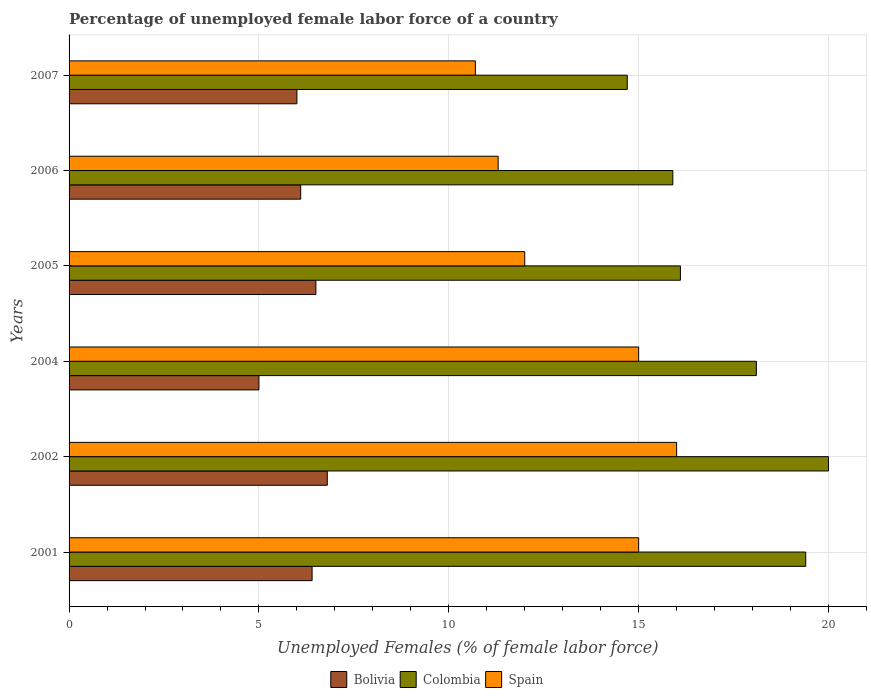How many groups of bars are there?
Provide a short and direct response. 6. Are the number of bars on each tick of the Y-axis equal?
Your answer should be very brief. Yes. How many bars are there on the 6th tick from the top?
Ensure brevity in your answer.  3. How many bars are there on the 2nd tick from the bottom?
Your response must be concise. 3. What is the label of the 4th group of bars from the top?
Ensure brevity in your answer.  2004. What is the percentage of unemployed female labor force in Colombia in 2004?
Your answer should be very brief. 18.1. Across all years, what is the maximum percentage of unemployed female labor force in Colombia?
Provide a succinct answer. 20. What is the total percentage of unemployed female labor force in Spain in the graph?
Provide a short and direct response. 80. What is the difference between the percentage of unemployed female labor force in Spain in 2004 and that in 2005?
Your response must be concise. 3. What is the average percentage of unemployed female labor force in Colombia per year?
Provide a succinct answer. 17.37. In the year 2007, what is the difference between the percentage of unemployed female labor force in Bolivia and percentage of unemployed female labor force in Colombia?
Provide a succinct answer. -8.7. What is the ratio of the percentage of unemployed female labor force in Spain in 2002 to that in 2007?
Provide a short and direct response. 1.5. What is the difference between the highest and the second highest percentage of unemployed female labor force in Colombia?
Offer a terse response. 0.6. What is the difference between the highest and the lowest percentage of unemployed female labor force in Bolivia?
Provide a succinct answer. 1.8. How many bars are there?
Your response must be concise. 18. How many years are there in the graph?
Give a very brief answer. 6. What is the difference between two consecutive major ticks on the X-axis?
Keep it short and to the point. 5. Are the values on the major ticks of X-axis written in scientific E-notation?
Offer a terse response. No. Does the graph contain grids?
Your answer should be very brief. Yes. Where does the legend appear in the graph?
Give a very brief answer. Bottom center. How many legend labels are there?
Offer a terse response. 3. What is the title of the graph?
Your answer should be compact. Percentage of unemployed female labor force of a country. What is the label or title of the X-axis?
Ensure brevity in your answer.  Unemployed Females (% of female labor force). What is the label or title of the Y-axis?
Provide a short and direct response. Years. What is the Unemployed Females (% of female labor force) of Bolivia in 2001?
Ensure brevity in your answer.  6.4. What is the Unemployed Females (% of female labor force) of Colombia in 2001?
Your response must be concise. 19.4. What is the Unemployed Females (% of female labor force) in Spain in 2001?
Provide a short and direct response. 15. What is the Unemployed Females (% of female labor force) in Bolivia in 2002?
Your response must be concise. 6.8. What is the Unemployed Females (% of female labor force) of Colombia in 2002?
Your response must be concise. 20. What is the Unemployed Females (% of female labor force) in Colombia in 2004?
Your response must be concise. 18.1. What is the Unemployed Females (% of female labor force) in Spain in 2004?
Provide a succinct answer. 15. What is the Unemployed Females (% of female labor force) of Colombia in 2005?
Provide a short and direct response. 16.1. What is the Unemployed Females (% of female labor force) of Spain in 2005?
Ensure brevity in your answer.  12. What is the Unemployed Females (% of female labor force) of Bolivia in 2006?
Provide a succinct answer. 6.1. What is the Unemployed Females (% of female labor force) in Colombia in 2006?
Your answer should be very brief. 15.9. What is the Unemployed Females (% of female labor force) in Spain in 2006?
Your answer should be compact. 11.3. What is the Unemployed Females (% of female labor force) of Bolivia in 2007?
Your answer should be very brief. 6. What is the Unemployed Females (% of female labor force) in Colombia in 2007?
Your answer should be very brief. 14.7. What is the Unemployed Females (% of female labor force) in Spain in 2007?
Provide a short and direct response. 10.7. Across all years, what is the maximum Unemployed Females (% of female labor force) in Bolivia?
Give a very brief answer. 6.8. Across all years, what is the minimum Unemployed Females (% of female labor force) of Bolivia?
Offer a terse response. 5. Across all years, what is the minimum Unemployed Females (% of female labor force) of Colombia?
Provide a short and direct response. 14.7. Across all years, what is the minimum Unemployed Females (% of female labor force) of Spain?
Your answer should be very brief. 10.7. What is the total Unemployed Females (% of female labor force) in Bolivia in the graph?
Keep it short and to the point. 36.8. What is the total Unemployed Females (% of female labor force) in Colombia in the graph?
Your answer should be compact. 104.2. What is the total Unemployed Females (% of female labor force) of Spain in the graph?
Ensure brevity in your answer.  80. What is the difference between the Unemployed Females (% of female labor force) in Spain in 2001 and that in 2002?
Keep it short and to the point. -1. What is the difference between the Unemployed Females (% of female labor force) of Bolivia in 2001 and that in 2004?
Your answer should be compact. 1.4. What is the difference between the Unemployed Females (% of female labor force) of Spain in 2001 and that in 2004?
Ensure brevity in your answer.  0. What is the difference between the Unemployed Females (% of female labor force) in Bolivia in 2001 and that in 2005?
Offer a terse response. -0.1. What is the difference between the Unemployed Females (% of female labor force) in Colombia in 2001 and that in 2005?
Make the answer very short. 3.3. What is the difference between the Unemployed Females (% of female labor force) of Spain in 2001 and that in 2006?
Ensure brevity in your answer.  3.7. What is the difference between the Unemployed Females (% of female labor force) of Spain in 2001 and that in 2007?
Offer a very short reply. 4.3. What is the difference between the Unemployed Females (% of female labor force) of Bolivia in 2002 and that in 2005?
Ensure brevity in your answer.  0.3. What is the difference between the Unemployed Females (% of female labor force) of Colombia in 2002 and that in 2005?
Make the answer very short. 3.9. What is the difference between the Unemployed Females (% of female labor force) in Spain in 2002 and that in 2005?
Provide a succinct answer. 4. What is the difference between the Unemployed Females (% of female labor force) in Spain in 2002 and that in 2006?
Offer a terse response. 4.7. What is the difference between the Unemployed Females (% of female labor force) of Colombia in 2002 and that in 2007?
Keep it short and to the point. 5.3. What is the difference between the Unemployed Females (% of female labor force) in Bolivia in 2004 and that in 2005?
Offer a terse response. -1.5. What is the difference between the Unemployed Females (% of female labor force) in Bolivia in 2004 and that in 2006?
Your answer should be compact. -1.1. What is the difference between the Unemployed Females (% of female labor force) of Colombia in 2005 and that in 2006?
Your answer should be very brief. 0.2. What is the difference between the Unemployed Females (% of female labor force) in Bolivia in 2005 and that in 2007?
Your response must be concise. 0.5. What is the difference between the Unemployed Females (% of female labor force) in Colombia in 2005 and that in 2007?
Your answer should be very brief. 1.4. What is the difference between the Unemployed Females (% of female labor force) of Spain in 2006 and that in 2007?
Give a very brief answer. 0.6. What is the difference between the Unemployed Females (% of female labor force) of Colombia in 2001 and the Unemployed Females (% of female labor force) of Spain in 2002?
Offer a very short reply. 3.4. What is the difference between the Unemployed Females (% of female labor force) in Bolivia in 2001 and the Unemployed Females (% of female labor force) in Colombia in 2007?
Offer a very short reply. -8.3. What is the difference between the Unemployed Females (% of female labor force) of Bolivia in 2001 and the Unemployed Females (% of female labor force) of Spain in 2007?
Offer a terse response. -4.3. What is the difference between the Unemployed Females (% of female labor force) in Colombia in 2002 and the Unemployed Females (% of female labor force) in Spain in 2004?
Your response must be concise. 5. What is the difference between the Unemployed Females (% of female labor force) in Bolivia in 2002 and the Unemployed Females (% of female labor force) in Spain in 2005?
Provide a short and direct response. -5.2. What is the difference between the Unemployed Females (% of female labor force) in Colombia in 2002 and the Unemployed Females (% of female labor force) in Spain in 2006?
Offer a very short reply. 8.7. What is the difference between the Unemployed Females (% of female labor force) in Bolivia in 2002 and the Unemployed Females (% of female labor force) in Spain in 2007?
Offer a very short reply. -3.9. What is the difference between the Unemployed Females (% of female labor force) in Colombia in 2002 and the Unemployed Females (% of female labor force) in Spain in 2007?
Give a very brief answer. 9.3. What is the difference between the Unemployed Females (% of female labor force) of Colombia in 2004 and the Unemployed Females (% of female labor force) of Spain in 2005?
Offer a terse response. 6.1. What is the difference between the Unemployed Females (% of female labor force) of Bolivia in 2004 and the Unemployed Females (% of female labor force) of Spain in 2006?
Ensure brevity in your answer.  -6.3. What is the difference between the Unemployed Females (% of female labor force) in Colombia in 2004 and the Unemployed Females (% of female labor force) in Spain in 2006?
Ensure brevity in your answer.  6.8. What is the difference between the Unemployed Females (% of female labor force) of Bolivia in 2005 and the Unemployed Females (% of female labor force) of Spain in 2006?
Your response must be concise. -4.8. What is the difference between the Unemployed Females (% of female labor force) in Bolivia in 2006 and the Unemployed Females (% of female labor force) in Colombia in 2007?
Give a very brief answer. -8.6. What is the difference between the Unemployed Females (% of female labor force) in Bolivia in 2006 and the Unemployed Females (% of female labor force) in Spain in 2007?
Your response must be concise. -4.6. What is the average Unemployed Females (% of female labor force) in Bolivia per year?
Keep it short and to the point. 6.13. What is the average Unemployed Females (% of female labor force) of Colombia per year?
Your answer should be very brief. 17.37. What is the average Unemployed Females (% of female labor force) of Spain per year?
Provide a short and direct response. 13.33. In the year 2002, what is the difference between the Unemployed Females (% of female labor force) of Bolivia and Unemployed Females (% of female labor force) of Colombia?
Make the answer very short. -13.2. In the year 2004, what is the difference between the Unemployed Females (% of female labor force) of Bolivia and Unemployed Females (% of female labor force) of Spain?
Make the answer very short. -10. In the year 2005, what is the difference between the Unemployed Females (% of female labor force) in Bolivia and Unemployed Females (% of female labor force) in Spain?
Give a very brief answer. -5.5. In the year 2005, what is the difference between the Unemployed Females (% of female labor force) in Colombia and Unemployed Females (% of female labor force) in Spain?
Provide a short and direct response. 4.1. In the year 2006, what is the difference between the Unemployed Females (% of female labor force) of Bolivia and Unemployed Females (% of female labor force) of Colombia?
Give a very brief answer. -9.8. In the year 2007, what is the difference between the Unemployed Females (% of female labor force) in Colombia and Unemployed Females (% of female labor force) in Spain?
Your answer should be compact. 4. What is the ratio of the Unemployed Females (% of female labor force) of Bolivia in 2001 to that in 2002?
Provide a succinct answer. 0.94. What is the ratio of the Unemployed Females (% of female labor force) of Colombia in 2001 to that in 2002?
Make the answer very short. 0.97. What is the ratio of the Unemployed Females (% of female labor force) of Spain in 2001 to that in 2002?
Offer a terse response. 0.94. What is the ratio of the Unemployed Females (% of female labor force) of Bolivia in 2001 to that in 2004?
Offer a terse response. 1.28. What is the ratio of the Unemployed Females (% of female labor force) of Colombia in 2001 to that in 2004?
Provide a succinct answer. 1.07. What is the ratio of the Unemployed Females (% of female labor force) in Spain in 2001 to that in 2004?
Make the answer very short. 1. What is the ratio of the Unemployed Females (% of female labor force) in Bolivia in 2001 to that in 2005?
Your answer should be very brief. 0.98. What is the ratio of the Unemployed Females (% of female labor force) of Colombia in 2001 to that in 2005?
Make the answer very short. 1.21. What is the ratio of the Unemployed Females (% of female labor force) in Bolivia in 2001 to that in 2006?
Keep it short and to the point. 1.05. What is the ratio of the Unemployed Females (% of female labor force) of Colombia in 2001 to that in 2006?
Your answer should be very brief. 1.22. What is the ratio of the Unemployed Females (% of female labor force) in Spain in 2001 to that in 2006?
Your answer should be very brief. 1.33. What is the ratio of the Unemployed Females (% of female labor force) in Bolivia in 2001 to that in 2007?
Offer a very short reply. 1.07. What is the ratio of the Unemployed Females (% of female labor force) of Colombia in 2001 to that in 2007?
Give a very brief answer. 1.32. What is the ratio of the Unemployed Females (% of female labor force) of Spain in 2001 to that in 2007?
Offer a very short reply. 1.4. What is the ratio of the Unemployed Females (% of female labor force) of Bolivia in 2002 to that in 2004?
Keep it short and to the point. 1.36. What is the ratio of the Unemployed Females (% of female labor force) of Colombia in 2002 to that in 2004?
Make the answer very short. 1.1. What is the ratio of the Unemployed Females (% of female labor force) in Spain in 2002 to that in 2004?
Ensure brevity in your answer.  1.07. What is the ratio of the Unemployed Females (% of female labor force) in Bolivia in 2002 to that in 2005?
Your answer should be compact. 1.05. What is the ratio of the Unemployed Females (% of female labor force) of Colombia in 2002 to that in 2005?
Ensure brevity in your answer.  1.24. What is the ratio of the Unemployed Females (% of female labor force) in Bolivia in 2002 to that in 2006?
Give a very brief answer. 1.11. What is the ratio of the Unemployed Females (% of female labor force) in Colombia in 2002 to that in 2006?
Provide a short and direct response. 1.26. What is the ratio of the Unemployed Females (% of female labor force) in Spain in 2002 to that in 2006?
Provide a succinct answer. 1.42. What is the ratio of the Unemployed Females (% of female labor force) in Bolivia in 2002 to that in 2007?
Your answer should be very brief. 1.13. What is the ratio of the Unemployed Females (% of female labor force) of Colombia in 2002 to that in 2007?
Provide a short and direct response. 1.36. What is the ratio of the Unemployed Females (% of female labor force) of Spain in 2002 to that in 2007?
Ensure brevity in your answer.  1.5. What is the ratio of the Unemployed Females (% of female labor force) in Bolivia in 2004 to that in 2005?
Your response must be concise. 0.77. What is the ratio of the Unemployed Females (% of female labor force) in Colombia in 2004 to that in 2005?
Give a very brief answer. 1.12. What is the ratio of the Unemployed Females (% of female labor force) in Spain in 2004 to that in 2005?
Provide a succinct answer. 1.25. What is the ratio of the Unemployed Females (% of female labor force) in Bolivia in 2004 to that in 2006?
Your answer should be compact. 0.82. What is the ratio of the Unemployed Females (% of female labor force) in Colombia in 2004 to that in 2006?
Offer a terse response. 1.14. What is the ratio of the Unemployed Females (% of female labor force) in Spain in 2004 to that in 2006?
Keep it short and to the point. 1.33. What is the ratio of the Unemployed Females (% of female labor force) in Colombia in 2004 to that in 2007?
Your answer should be compact. 1.23. What is the ratio of the Unemployed Females (% of female labor force) in Spain in 2004 to that in 2007?
Provide a succinct answer. 1.4. What is the ratio of the Unemployed Females (% of female labor force) of Bolivia in 2005 to that in 2006?
Offer a very short reply. 1.07. What is the ratio of the Unemployed Females (% of female labor force) in Colombia in 2005 to that in 2006?
Offer a very short reply. 1.01. What is the ratio of the Unemployed Females (% of female labor force) of Spain in 2005 to that in 2006?
Your answer should be very brief. 1.06. What is the ratio of the Unemployed Females (% of female labor force) in Bolivia in 2005 to that in 2007?
Provide a short and direct response. 1.08. What is the ratio of the Unemployed Females (% of female labor force) in Colombia in 2005 to that in 2007?
Make the answer very short. 1.1. What is the ratio of the Unemployed Females (% of female labor force) in Spain in 2005 to that in 2007?
Your answer should be compact. 1.12. What is the ratio of the Unemployed Females (% of female labor force) of Bolivia in 2006 to that in 2007?
Offer a very short reply. 1.02. What is the ratio of the Unemployed Females (% of female labor force) in Colombia in 2006 to that in 2007?
Offer a very short reply. 1.08. What is the ratio of the Unemployed Females (% of female labor force) in Spain in 2006 to that in 2007?
Your answer should be compact. 1.06. What is the difference between the highest and the lowest Unemployed Females (% of female labor force) in Bolivia?
Offer a terse response. 1.8. What is the difference between the highest and the lowest Unemployed Females (% of female labor force) in Colombia?
Your answer should be very brief. 5.3. 